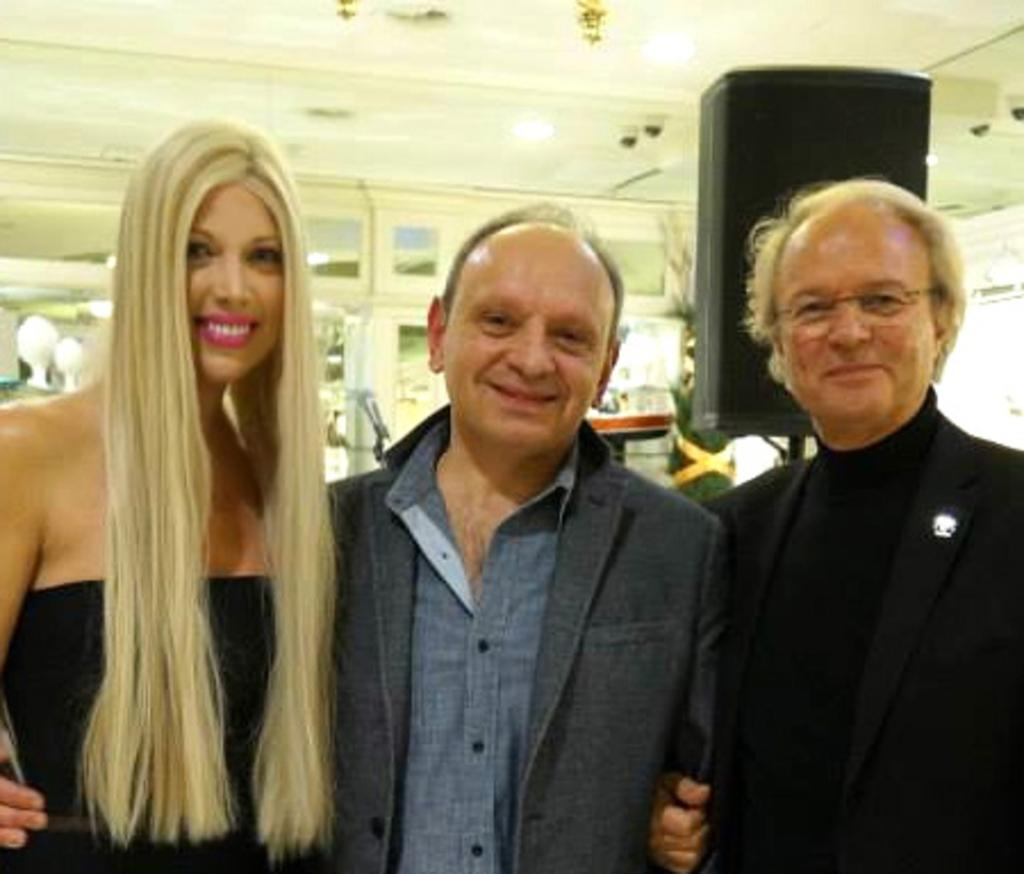Who or what is present in the image? There are people in the image. What is the facial expression of the people in the image? The people are smiling. What can be seen in the background of the image? There are lights visible in the background of the image. What type of sofa is visible in the image? There is no sofa present in the image. 